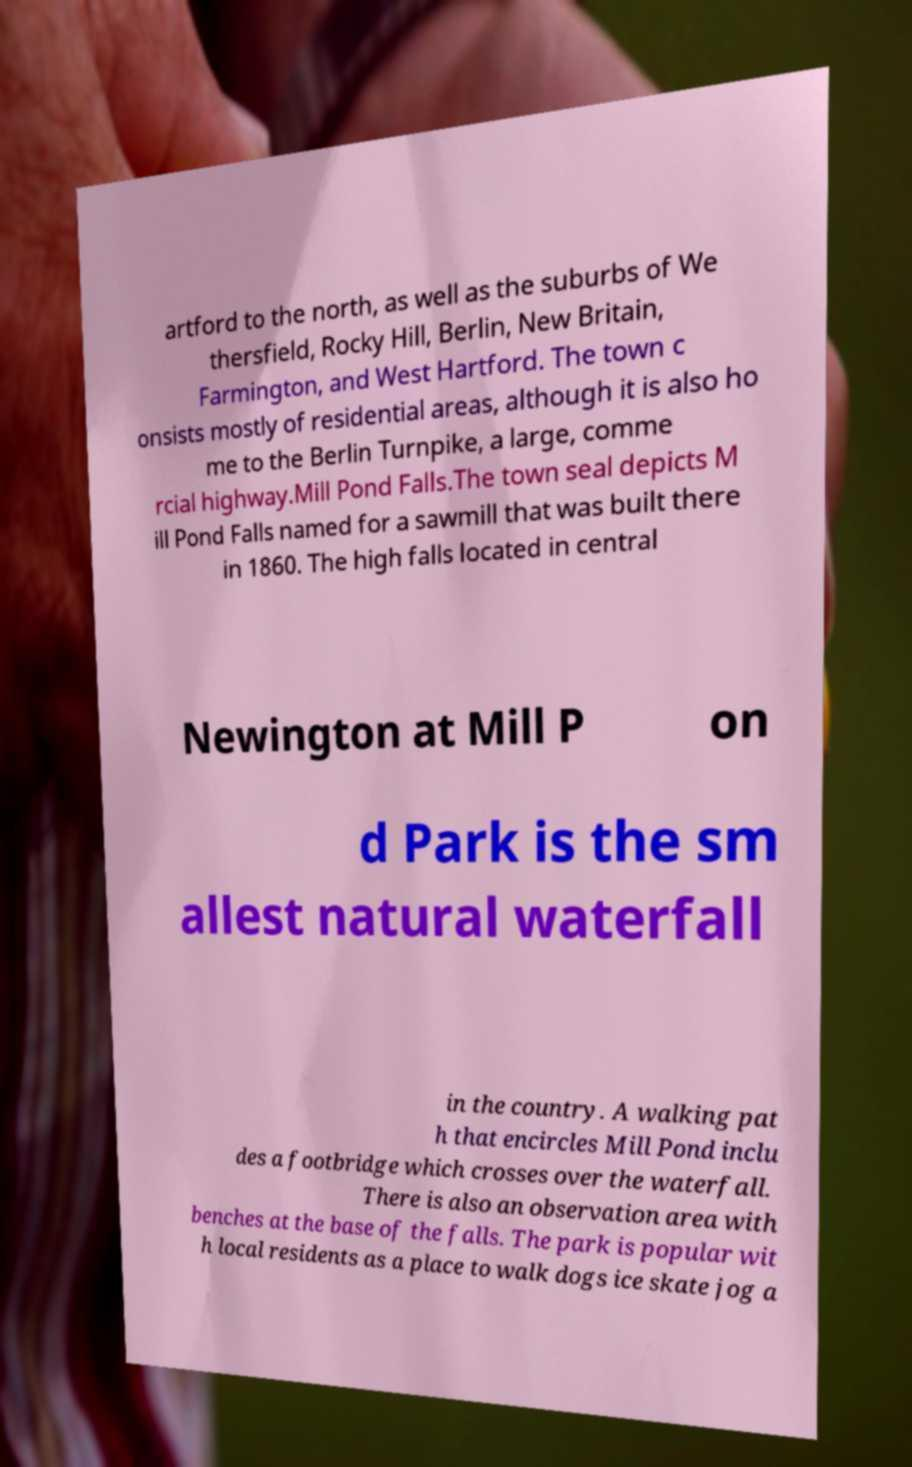Could you extract and type out the text from this image? artford to the north, as well as the suburbs of We thersfield, Rocky Hill, Berlin, New Britain, Farmington, and West Hartford. The town c onsists mostly of residential areas, although it is also ho me to the Berlin Turnpike, a large, comme rcial highway.Mill Pond Falls.The town seal depicts M ill Pond Falls named for a sawmill that was built there in 1860. The high falls located in central Newington at Mill P on d Park is the sm allest natural waterfall in the country. A walking pat h that encircles Mill Pond inclu des a footbridge which crosses over the waterfall. There is also an observation area with benches at the base of the falls. The park is popular wit h local residents as a place to walk dogs ice skate jog a 